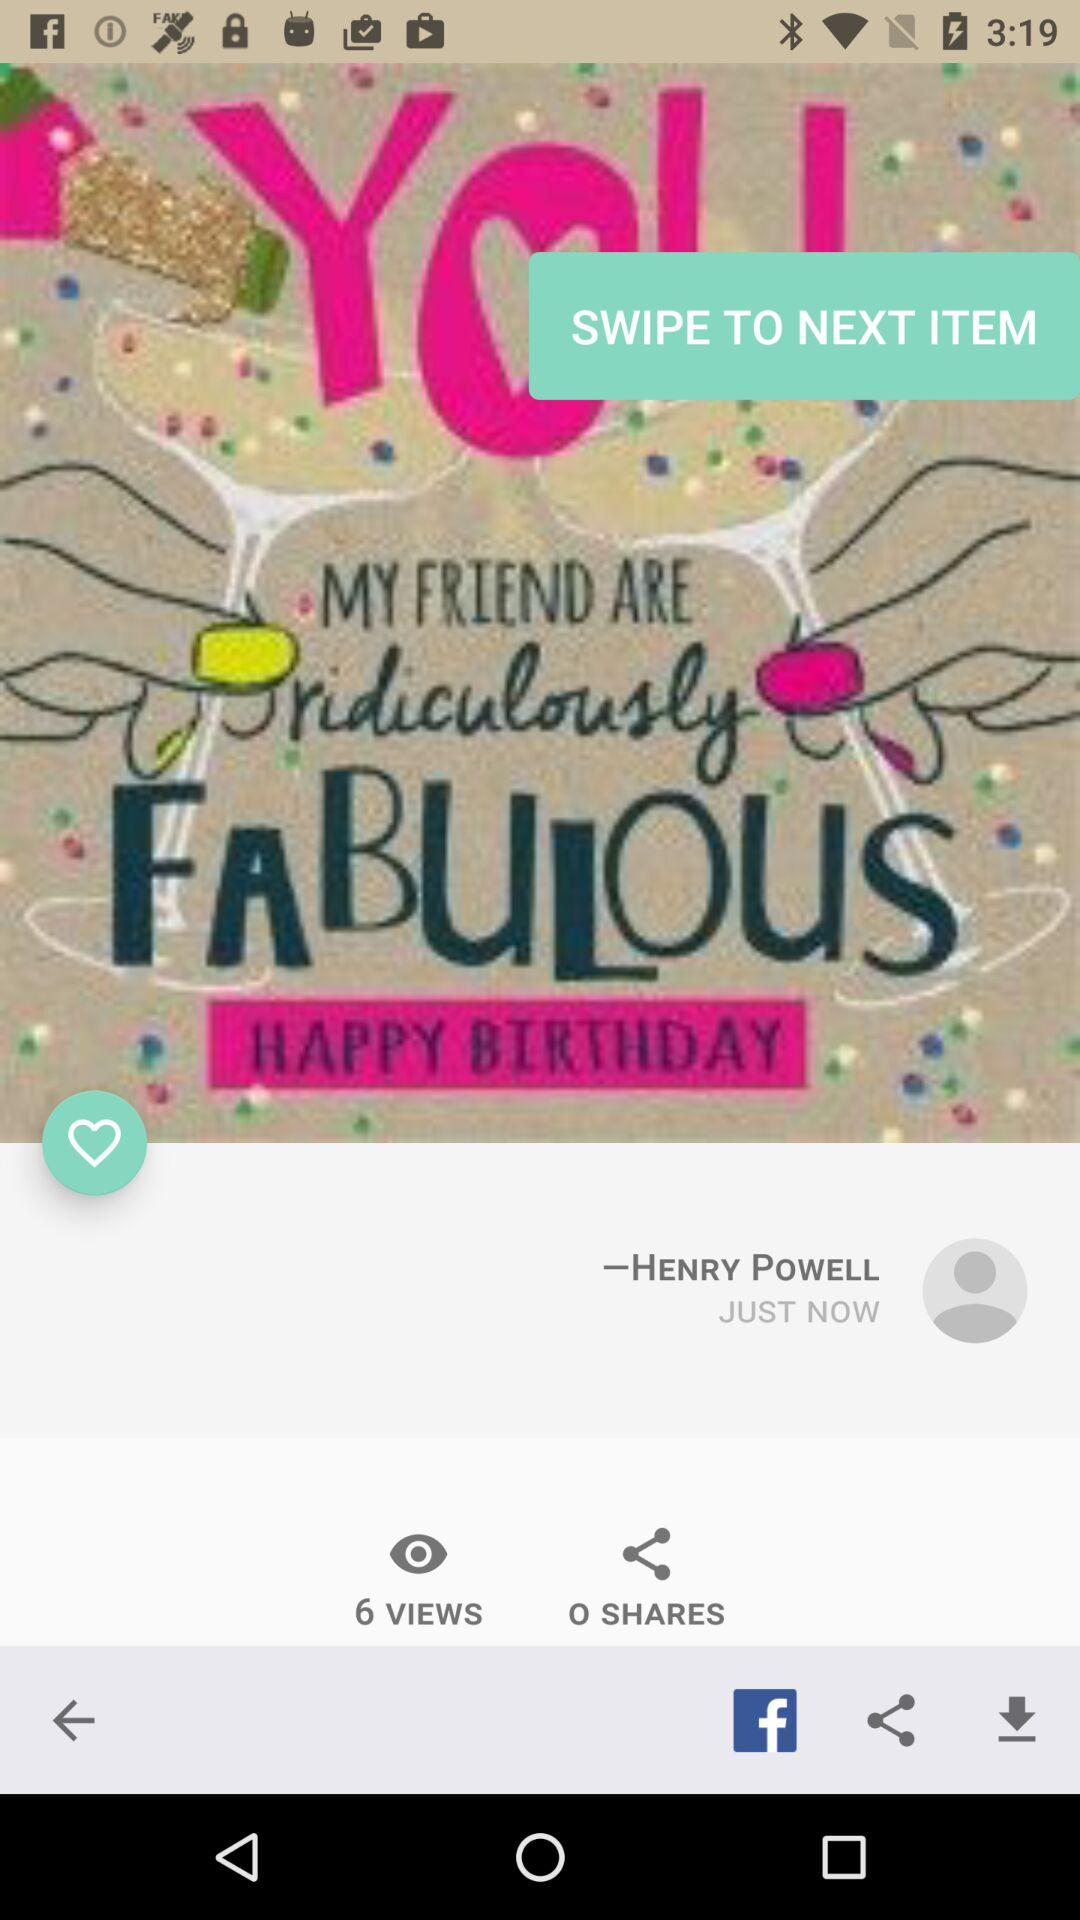When was the photo posted? The photo was posted just now. 